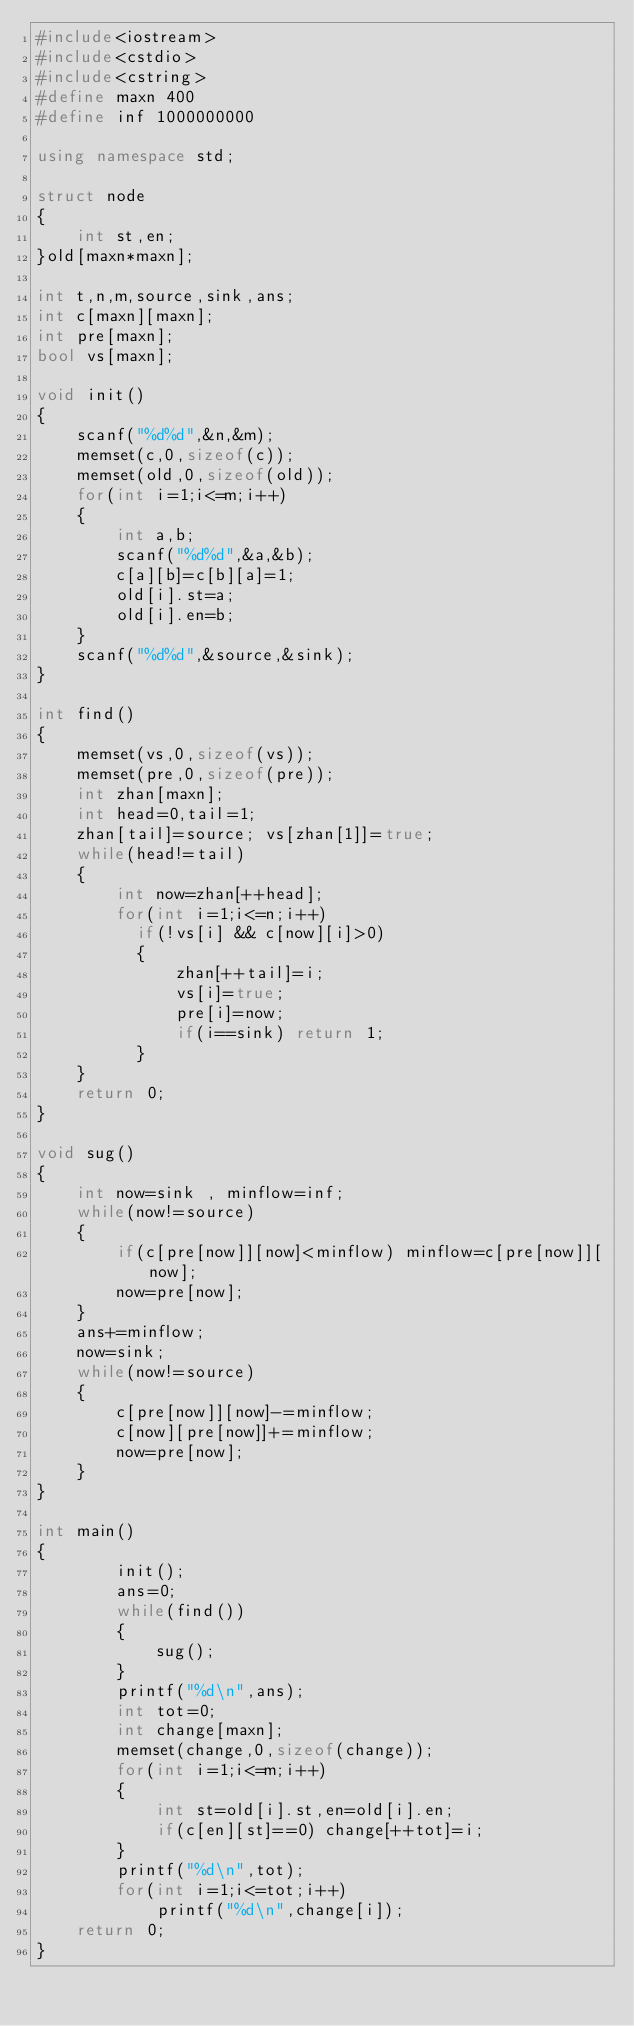Convert code to text. <code><loc_0><loc_0><loc_500><loc_500><_C++_>#include<iostream>
#include<cstdio>
#include<cstring>
#define maxn 400
#define inf 1000000000

using namespace std;

struct node
{
    int st,en;
}old[maxn*maxn];

int t,n,m,source,sink,ans;
int c[maxn][maxn];
int pre[maxn];
bool vs[maxn];

void init()
{
    scanf("%d%d",&n,&m);
    memset(c,0,sizeof(c));
    memset(old,0,sizeof(old));
    for(int i=1;i<=m;i++)
    {
        int a,b;
        scanf("%d%d",&a,&b);
        c[a][b]=c[b][a]=1;
        old[i].st=a;
        old[i].en=b;
    }
    scanf("%d%d",&source,&sink);
}

int find()
{
    memset(vs,0,sizeof(vs));
    memset(pre,0,sizeof(pre));
    int zhan[maxn];
    int head=0,tail=1;
    zhan[tail]=source; vs[zhan[1]]=true;
    while(head!=tail)
    {
        int now=zhan[++head];
        for(int i=1;i<=n;i++)
          if(!vs[i] && c[now][i]>0)
          {
              zhan[++tail]=i;
              vs[i]=true;
              pre[i]=now;
              if(i==sink) return 1;
          }
    }
    return 0;
}

void sug()
{
    int now=sink , minflow=inf;
    while(now!=source)
    {
        if(c[pre[now]][now]<minflow) minflow=c[pre[now]][now];
        now=pre[now];
    }
    ans+=minflow;
    now=sink;
    while(now!=source)
    {
        c[pre[now]][now]-=minflow;
        c[now][pre[now]]+=minflow;
        now=pre[now];
    }
}

int main()
{
        init();
        ans=0;
        while(find())
        {
            sug();
        }
        printf("%d\n",ans);
        int tot=0;
        int change[maxn];
        memset(change,0,sizeof(change));
        for(int i=1;i<=m;i++)
        {
            int st=old[i].st,en=old[i].en;
            if(c[en][st]==0) change[++tot]=i;
        }
        printf("%d\n",tot);
        for(int i=1;i<=tot;i++)
            printf("%d\n",change[i]);
    return 0;
}</code> 